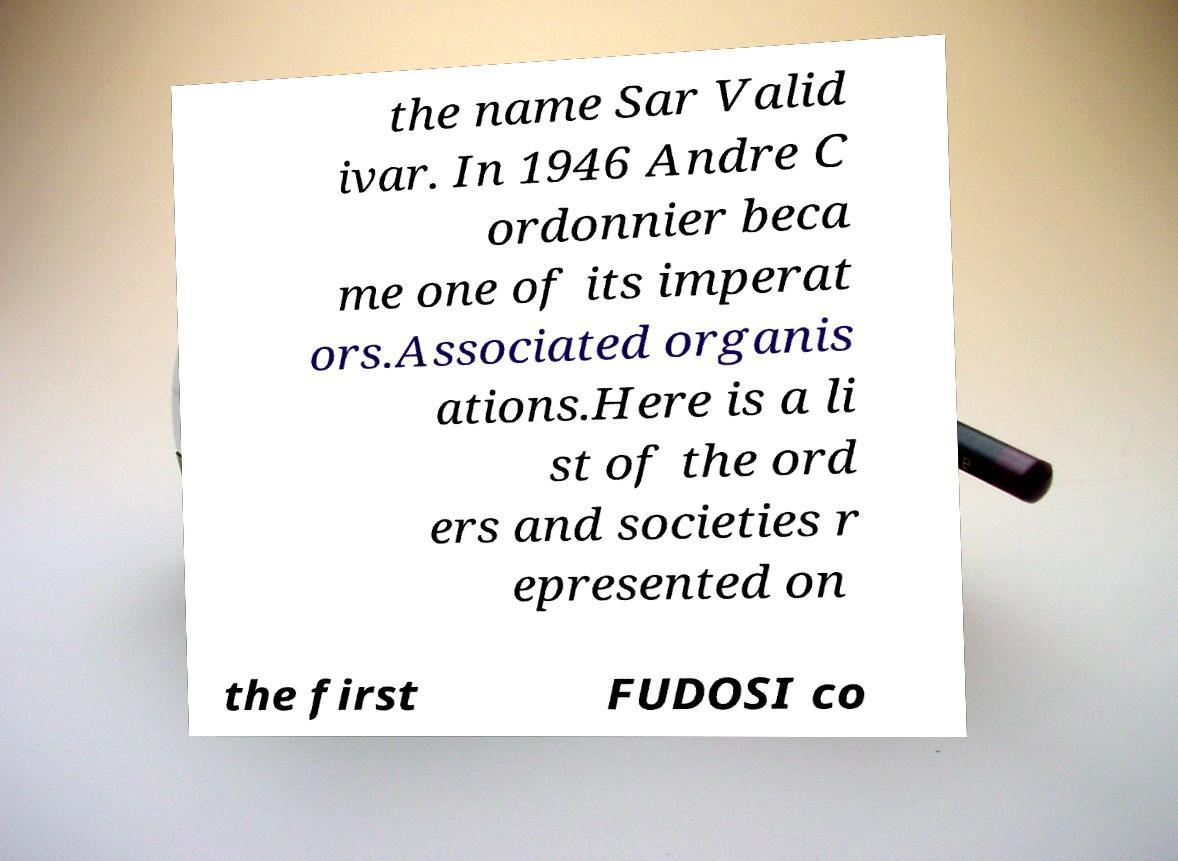Can you read and provide the text displayed in the image?This photo seems to have some interesting text. Can you extract and type it out for me? the name Sar Valid ivar. In 1946 Andre C ordonnier beca me one of its imperat ors.Associated organis ations.Here is a li st of the ord ers and societies r epresented on the first FUDOSI co 